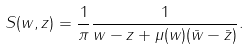<formula> <loc_0><loc_0><loc_500><loc_500>S ( w , z ) = \frac { 1 } { \pi } \frac { 1 } { w - z + \mu ( w ) ( \bar { w } - \bar { z } ) } .</formula> 